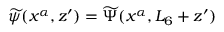<formula> <loc_0><loc_0><loc_500><loc_500>\widetilde { \psi } ( x ^ { \alpha } , z ^ { \prime } ) = \widetilde { \Psi } ( x ^ { \alpha } , L _ { 6 } + z ^ { \prime } )</formula> 